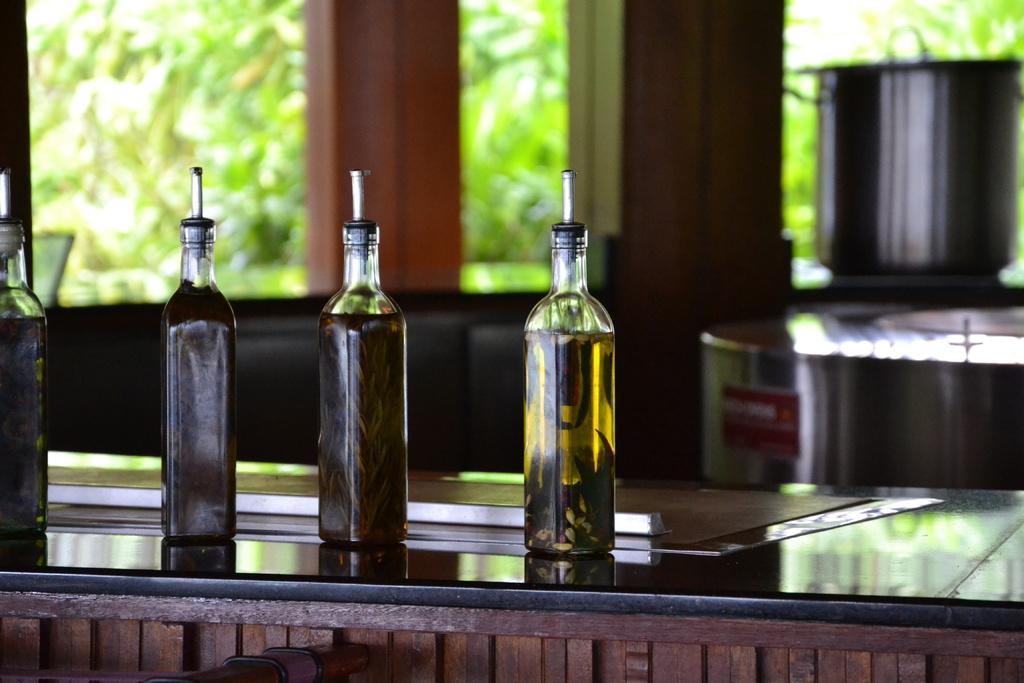How many bottles are visible in the image? There are four bottles in the image. Where are the bottles located? The bottles are placed on a table. What else can be seen in the background of the image? There is a dish, pillars, and trees in the background of the image. What type of paint is being used on the stage in the image? There is no stage or paint present in the image. Is there a camp visible in the background of the image? There is no camp visible in the image; only trees, pillars, and a dish are present in the background. 